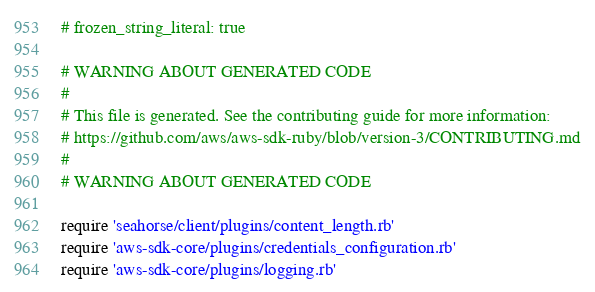Convert code to text. <code><loc_0><loc_0><loc_500><loc_500><_Ruby_># frozen_string_literal: true

# WARNING ABOUT GENERATED CODE
#
# This file is generated. See the contributing guide for more information:
# https://github.com/aws/aws-sdk-ruby/blob/version-3/CONTRIBUTING.md
#
# WARNING ABOUT GENERATED CODE

require 'seahorse/client/plugins/content_length.rb'
require 'aws-sdk-core/plugins/credentials_configuration.rb'
require 'aws-sdk-core/plugins/logging.rb'</code> 